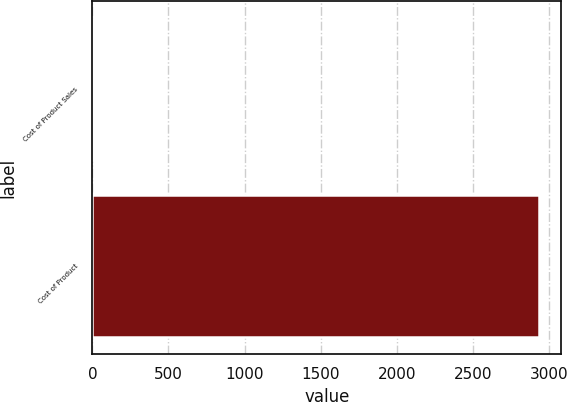Convert chart. <chart><loc_0><loc_0><loc_500><loc_500><bar_chart><fcel>Cost of Product Sales<fcel>Cost of Product<nl><fcel>5<fcel>2934<nl></chart> 